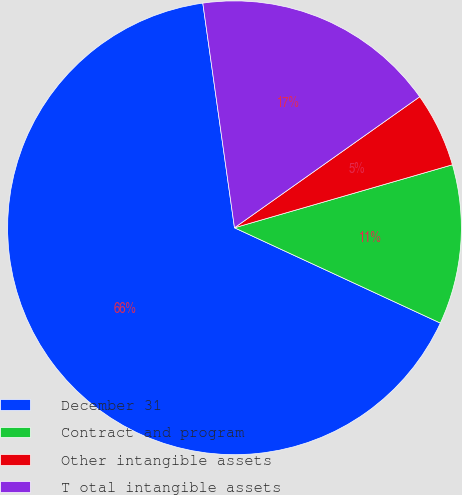Convert chart. <chart><loc_0><loc_0><loc_500><loc_500><pie_chart><fcel>December 31<fcel>Contract and program<fcel>Other intangible assets<fcel>T otal intangible assets<nl><fcel>65.87%<fcel>11.38%<fcel>5.32%<fcel>17.43%<nl></chart> 